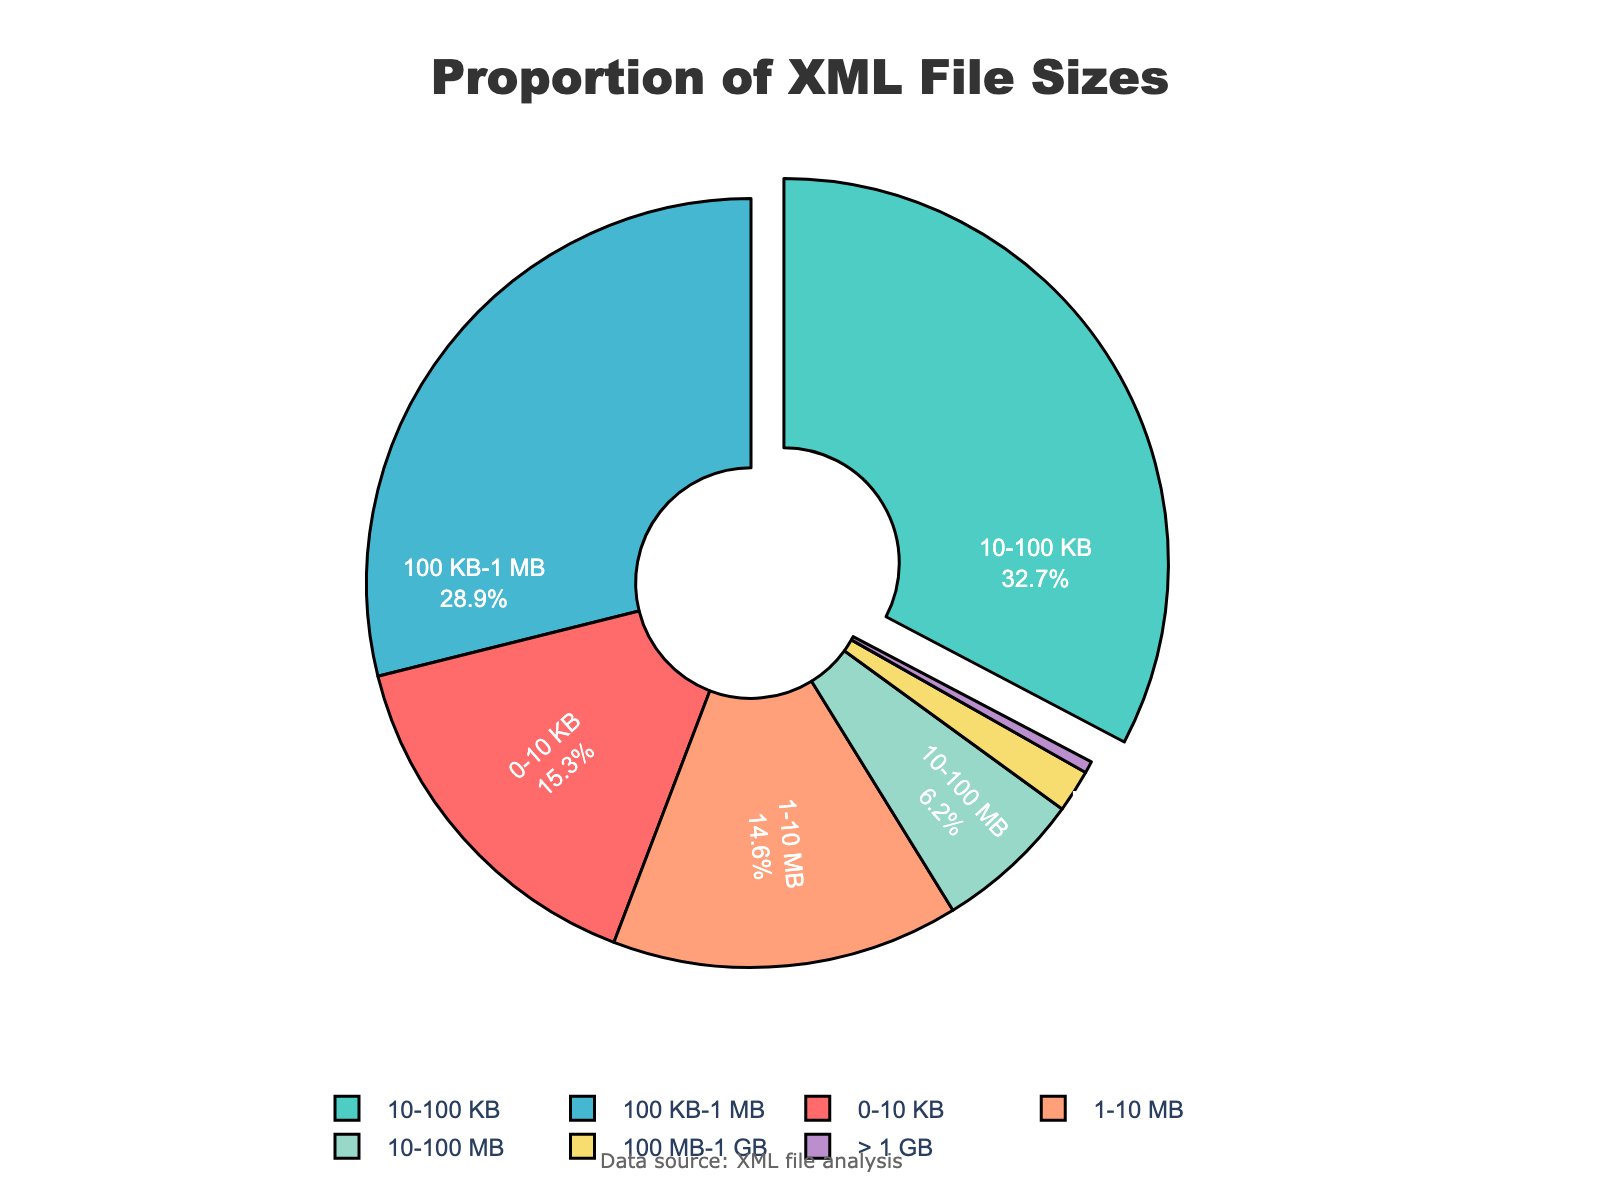What size range has the largest percentage of XML files? Look at the pie chart and identify the section with the largest piece. The "10-100 KB" segment is the largest.
Answer: 10-100 KB What combined percentage of XML files are less than 1 MB? Sum the percentages of the first three segments (0-10 KB, 10-100 KB, 100 KB-1 MB). 15.3% + 32.7% + 28.9%.
Answer: 76.9% How much larger is the '10-100 KB' segment compared to the '1-10 MB' segment? Subtract the percentage of '1-10 MB' from '10-100 KB'. 32.7% - 14.6%.
Answer: 18.1% Which segment is represented by a green color? Visually identify the segment with the green color, which corresponds to the '10-100 KB'.
Answer: 10-100 KB What is the difference in percentage between XML files in the '100 KB - 1 MB' and '> 1 GB' ranges? Subtract the percentage of '> 1 GB' from '100 KB - 1 MB'. 28.9% - 0.5%.
Answer: 28.4% What is the percentage of XML files that are larger than 100 MB? Sum the percentages of '100 MB-1 GB' and '> 1 GB'. 1.8% + 0.5%.
Answer: 2.3% Which range has the smallest proportion of XML files? Look at the pie chart and identify the smallest section, which is '> 1 GB'.
Answer: > 1 GB 